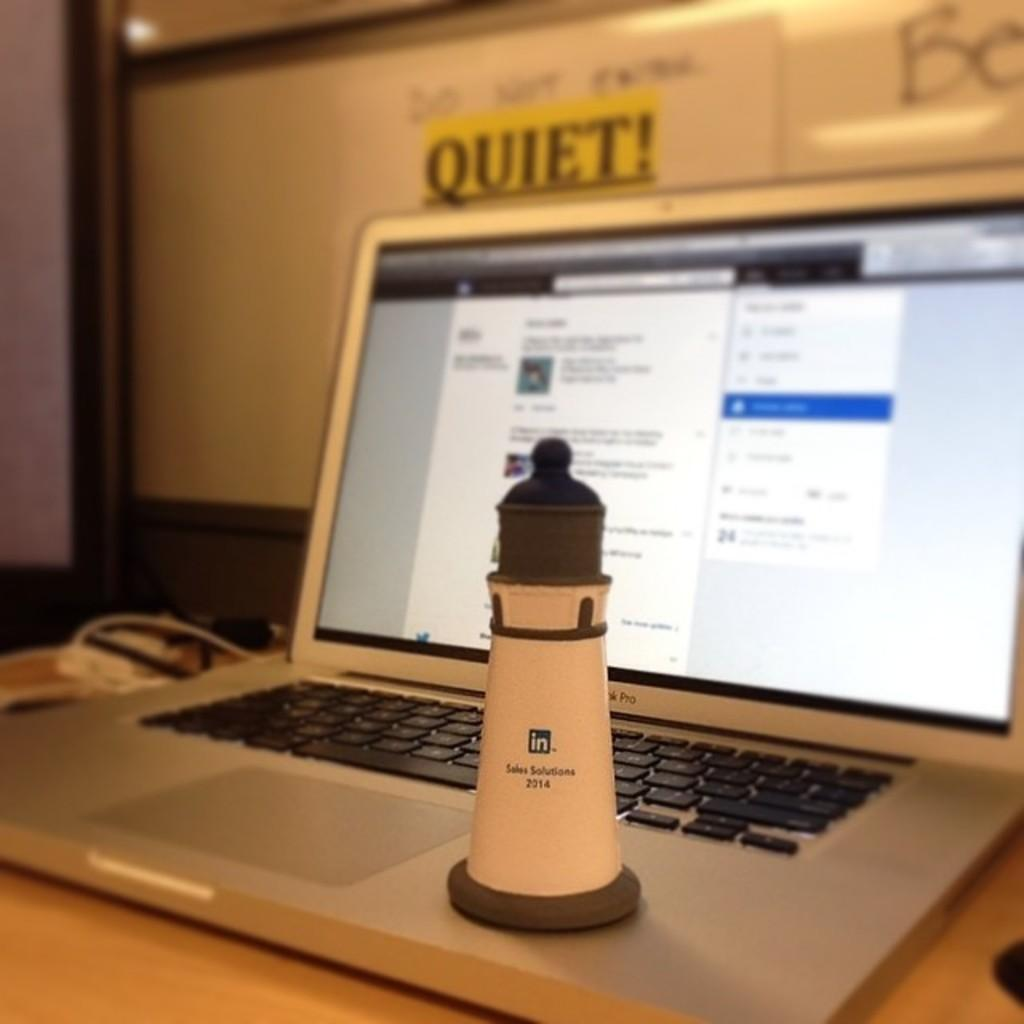<image>
Give a short and clear explanation of the subsequent image. Lighthouse sits on a laptop with the word quiet! behind it. 